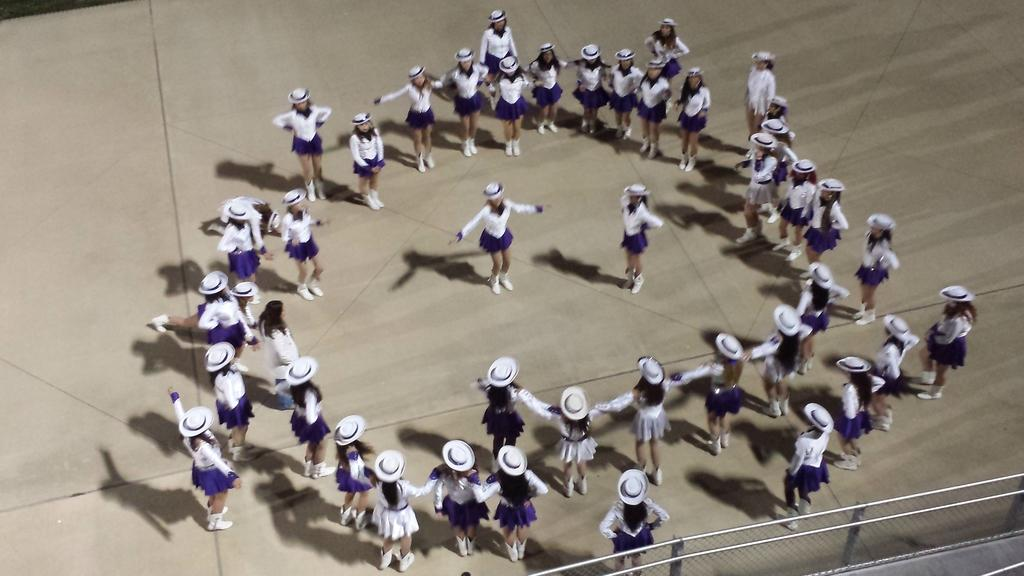What is the main subject of the image? The main subject of the image is a group of girls. How are the girls positioned in the image? The girls are standing in a circular manner and holding each other's hands. Are there any specific details about the girls in the middle of the group? Yes, there are two girls in the middle of the group. What can be seen at the bottom of the image? There is a fence at the bottom of the image. What type of animals can be seen in the zoo in the image? There is no zoo or animals present in the image; it features a group of girls standing in a circular manner. 